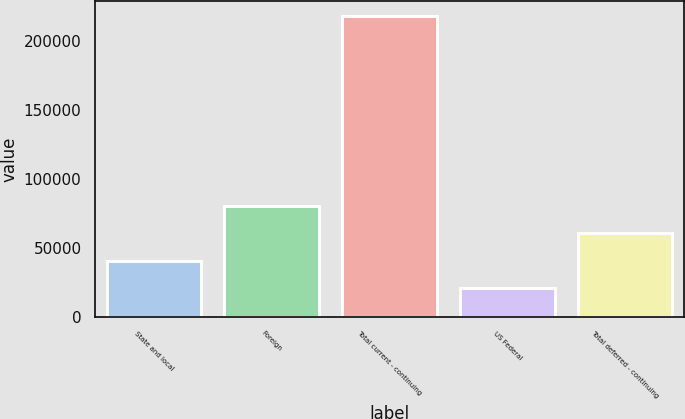Convert chart. <chart><loc_0><loc_0><loc_500><loc_500><bar_chart><fcel>State and local<fcel>Foreign<fcel>Total current - continuing<fcel>US Federal<fcel>Total deferred - continuing<nl><fcel>40866.5<fcel>80185.5<fcel>217802<fcel>21207<fcel>60526<nl></chart> 